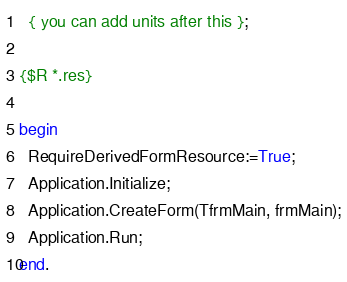<code> <loc_0><loc_0><loc_500><loc_500><_Pascal_>  { you can add units after this };

{$R *.res}

begin
  RequireDerivedFormResource:=True;
  Application.Initialize;
  Application.CreateForm(TfrmMain, frmMain);
  Application.Run;
end.

</code> 